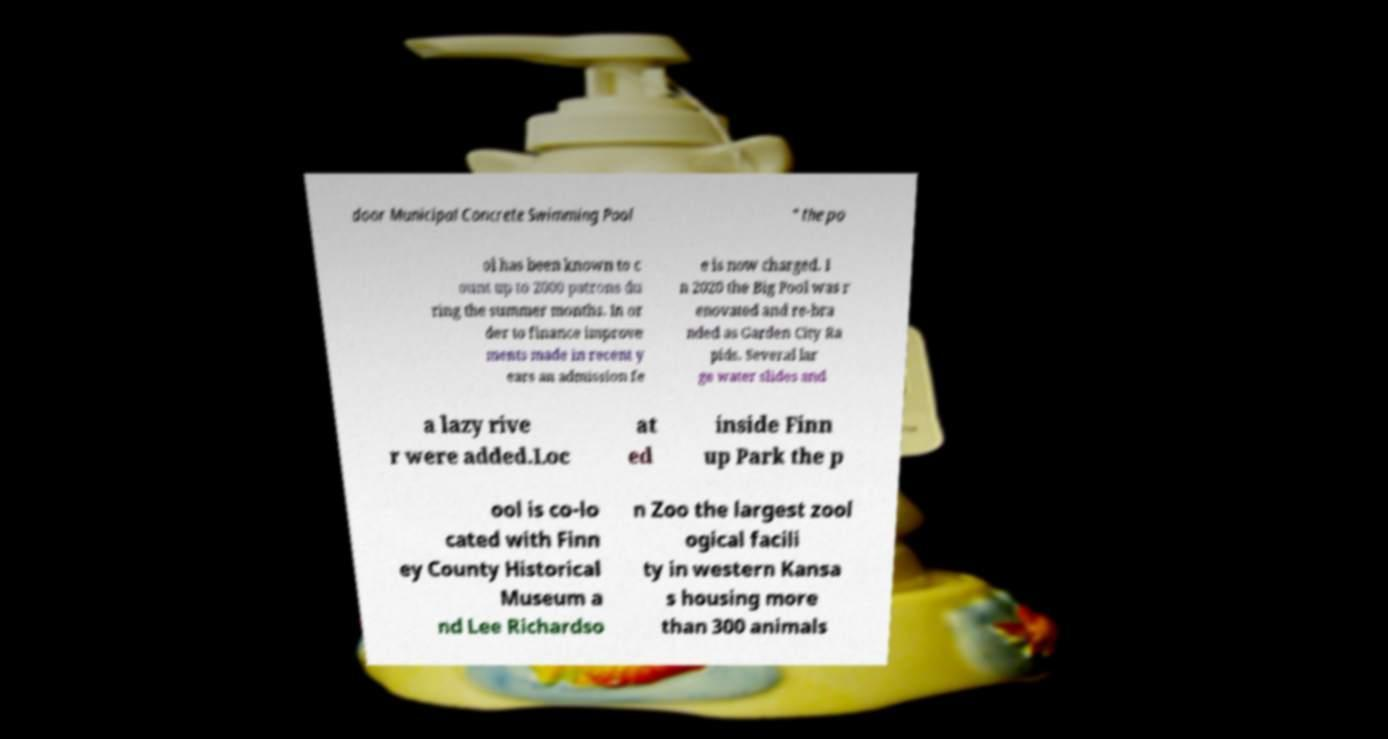Please identify and transcribe the text found in this image. door Municipal Concrete Swimming Pool " the po ol has been known to c ount up to 2000 patrons du ring the summer months. In or der to finance improve ments made in recent y ears an admission fe e is now charged. I n 2020 the Big Pool was r enovated and re-bra nded as Garden City Ra pids. Several lar ge water slides and a lazy rive r were added.Loc at ed inside Finn up Park the p ool is co-lo cated with Finn ey County Historical Museum a nd Lee Richardso n Zoo the largest zool ogical facili ty in western Kansa s housing more than 300 animals 